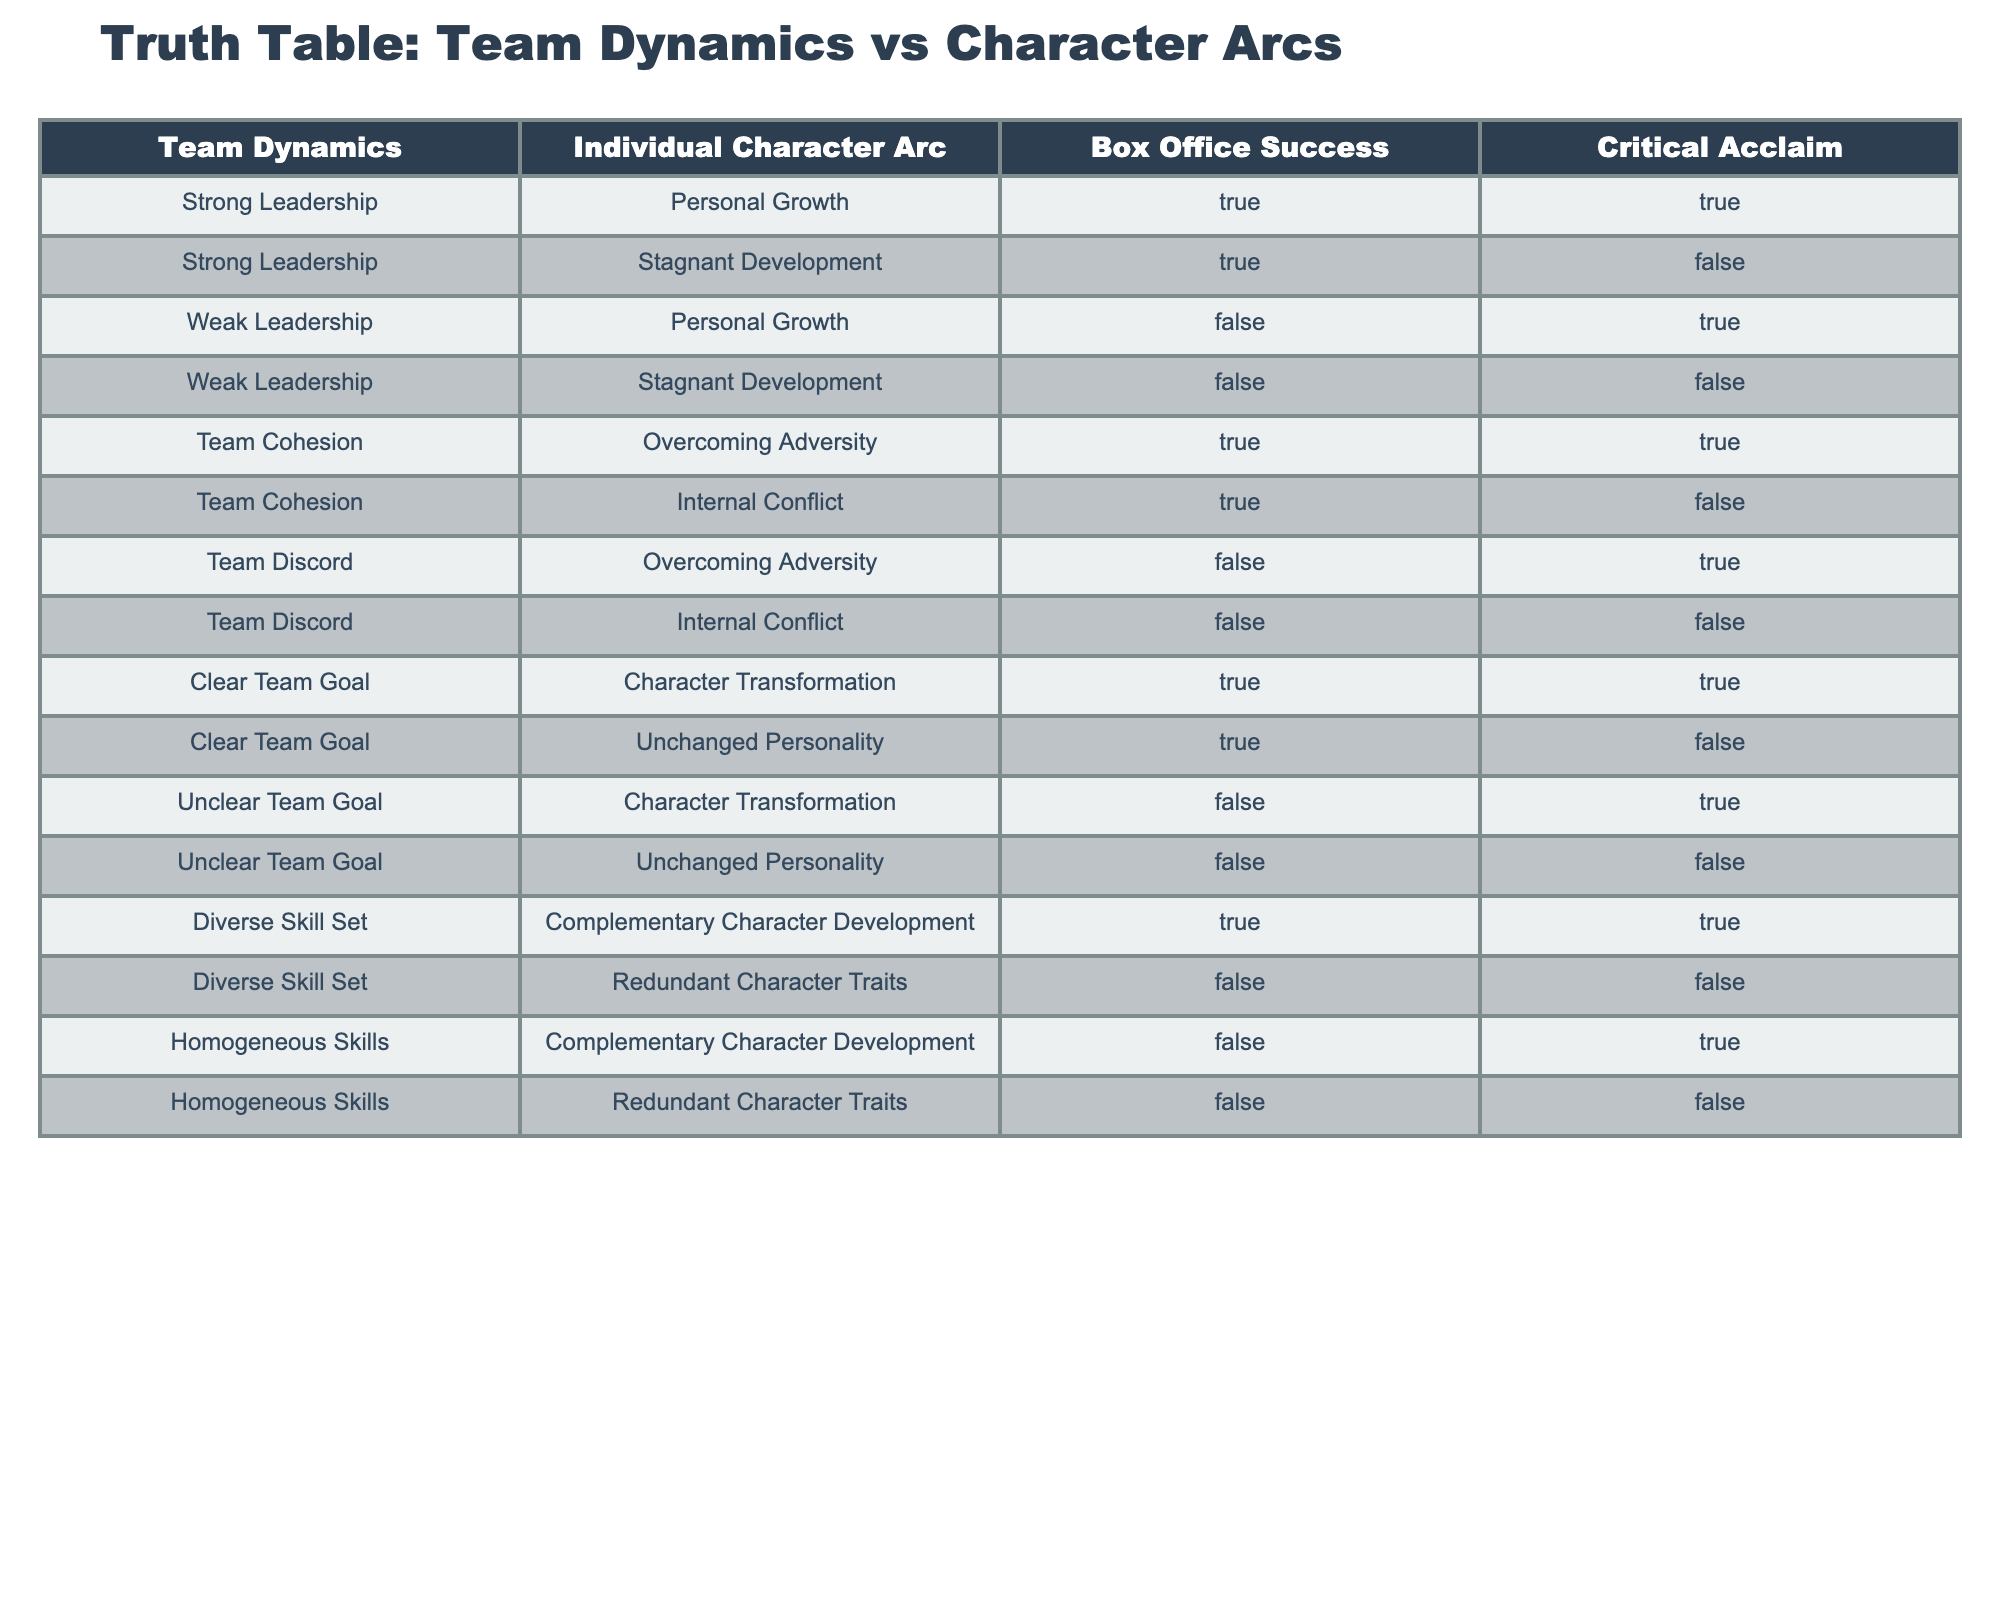What is the box office success rate for movies featuring strong leadership and personal growth? There are two rows in the table where strong leadership is paired with personal growth. Both of these rows show box office success as true. Therefore, the success rate is 100%.
Answer: 100% What is the critical acclaim for films with weak leadership and stagnant development? There is one entry for weak leadership and stagnant development in the table, and it shows critical acclaim as false. Therefore, the critical acclaim for this combination is 0%.
Answer: 0% Which team dynamic results in character transformation without achieving box office success? The table shows that unclear team goal and character transformation is the only combination where there is no box office success. Hence, this is the combination being sought.
Answer: unclear team goal and character transformation How many entries in the table indicate that strong leadership leads to critical acclaim? There are two entries that include strong leadership: one with personal growth (true critical acclaim) and another with stagnant development (false critical acclaim). Only one indicates true critical acclaim.
Answer: 1 Do movies characterized by team discord always lead to internal conflict? In the table, there are two entries for team discord. One shows internal conflict (false box office success; false critical acclaim), and the other shows overcoming adversity (false box office success; true critical acclaim). Hence, team discord does not always lead to internal conflict.
Answer: No What is the relationship between a clear team goal and box office success when the character transformations occur? The table shows that for a clear team goal and character transformation, there is indeed box office success (true). Hence, this relationship is positive, confirming that clear team goal positively affects box office success regarding character transformation.
Answer: Positive relationship Is there a combination that achieves box office success and critical acclaim for homogeneous skills? The table shows no entries for homogeneous skills achieving box office success and critical acclaim; hence, this combination does not exist.
Answer: No What is the number of combinations that result in personal growth? The table shows three entries that include personal growth: strong leadership with personal growth (true, true), weak leadership with personal growth (false, true), and team cohesion with overcoming adversity (true, true). Therefore, the total number of combinations resulting in personal growth is three.
Answer: 3 